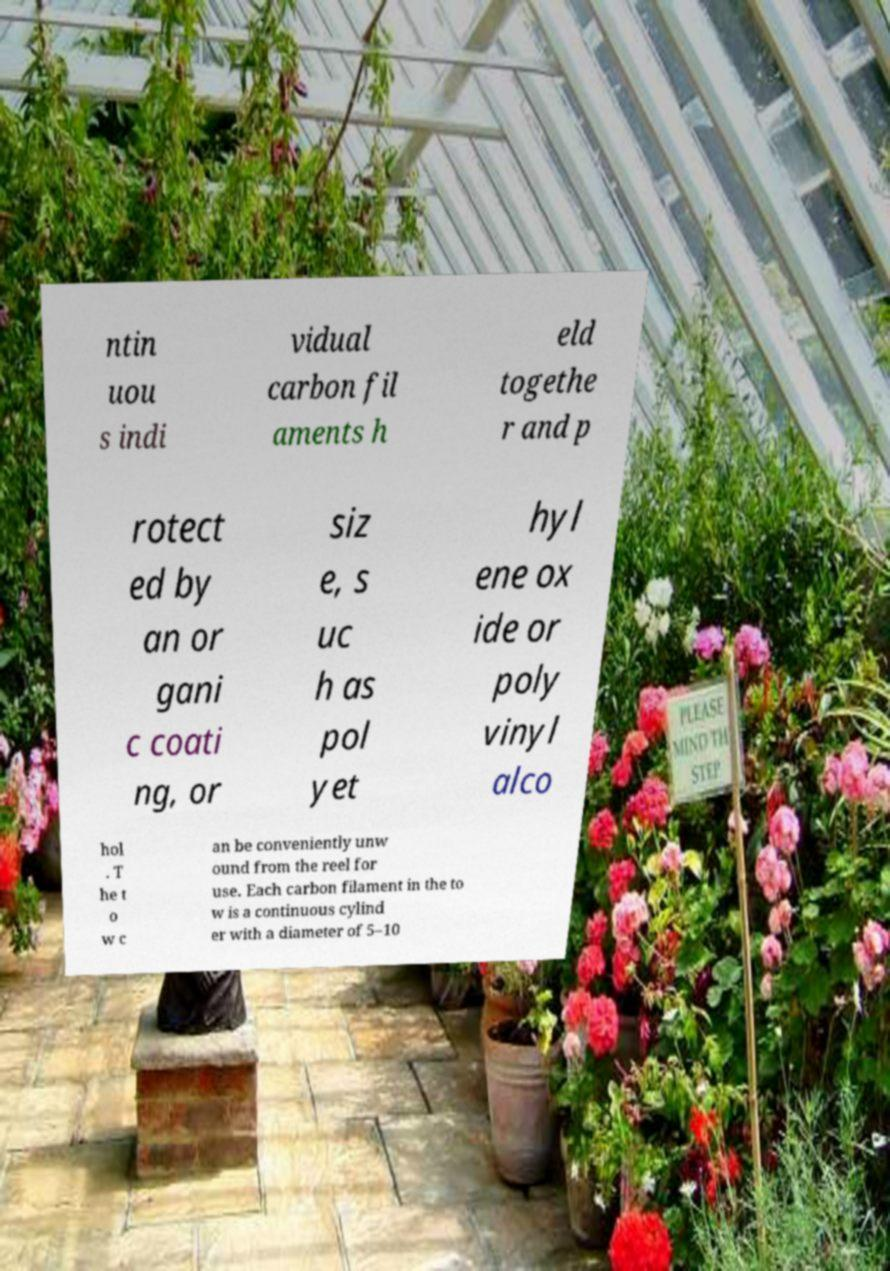Please identify and transcribe the text found in this image. ntin uou s indi vidual carbon fil aments h eld togethe r and p rotect ed by an or gani c coati ng, or siz e, s uc h as pol yet hyl ene ox ide or poly vinyl alco hol . T he t o w c an be conveniently unw ound from the reel for use. Each carbon filament in the to w is a continuous cylind er with a diameter of 5–10 